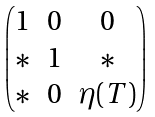Convert formula to latex. <formula><loc_0><loc_0><loc_500><loc_500>\begin{pmatrix} 1 & 0 & 0 \\ * & 1 & * \\ * & 0 & \eta ( T ) \end{pmatrix}</formula> 